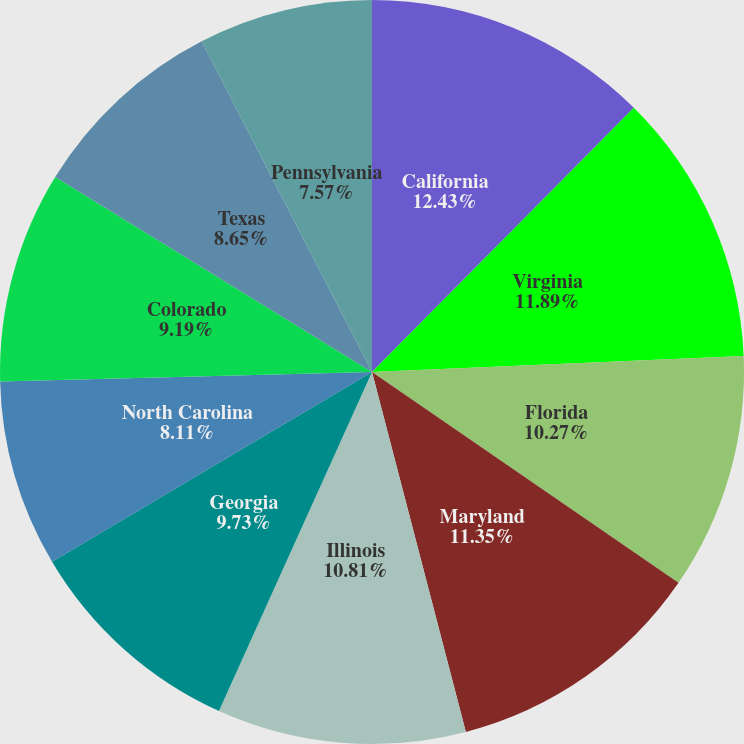<chart> <loc_0><loc_0><loc_500><loc_500><pie_chart><fcel>California<fcel>Virginia<fcel>Florida<fcel>Maryland<fcel>Illinois<fcel>Georgia<fcel>North Carolina<fcel>Colorado<fcel>Texas<fcel>Pennsylvania<nl><fcel>12.43%<fcel>11.89%<fcel>10.27%<fcel>11.35%<fcel>10.81%<fcel>9.73%<fcel>8.11%<fcel>9.19%<fcel>8.65%<fcel>7.57%<nl></chart> 